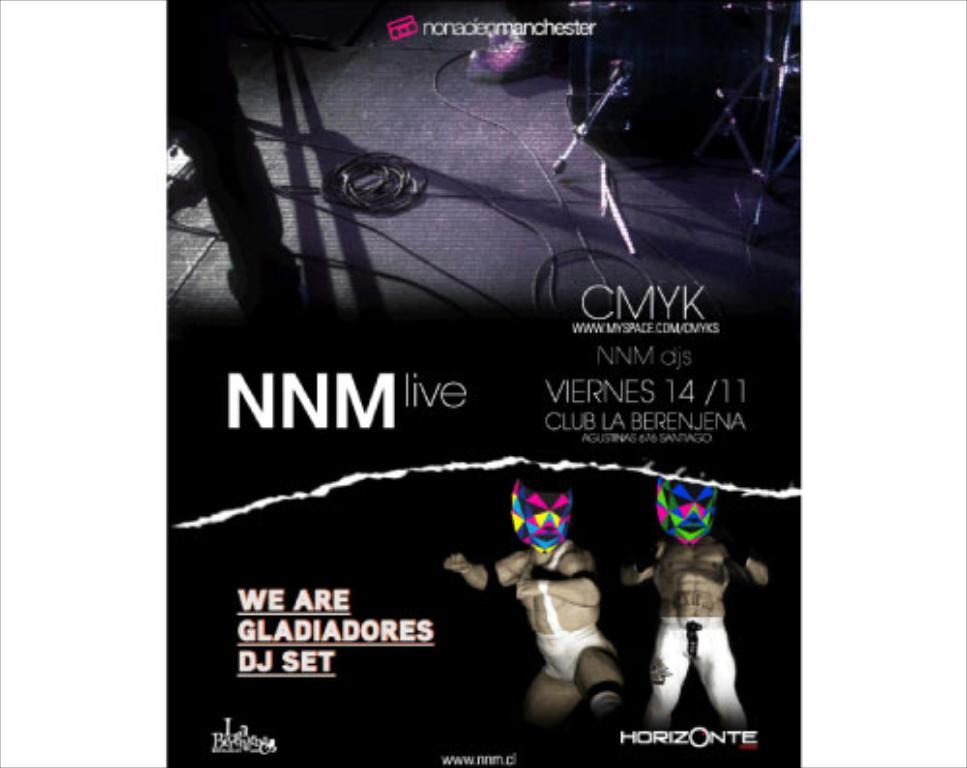<image>
Share a concise interpretation of the image provided. An advertisement for a club announces that there will be a set by We are Gladiators. 